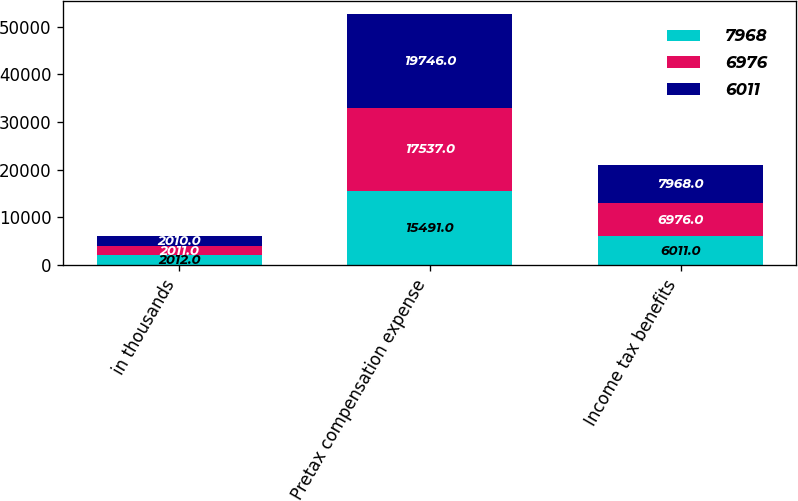Convert chart. <chart><loc_0><loc_0><loc_500><loc_500><stacked_bar_chart><ecel><fcel>in thousands<fcel>Pretax compensation expense<fcel>Income tax benefits<nl><fcel>7968<fcel>2012<fcel>15491<fcel>6011<nl><fcel>6976<fcel>2011<fcel>17537<fcel>6976<nl><fcel>6011<fcel>2010<fcel>19746<fcel>7968<nl></chart> 